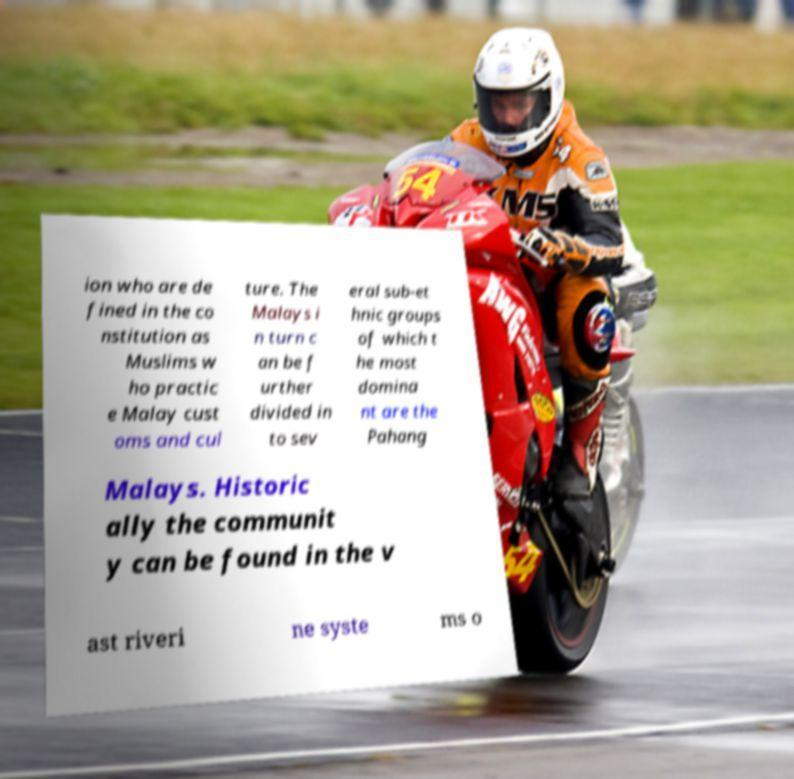There's text embedded in this image that I need extracted. Can you transcribe it verbatim? ion who are de fined in the co nstitution as Muslims w ho practic e Malay cust oms and cul ture. The Malays i n turn c an be f urther divided in to sev eral sub-et hnic groups of which t he most domina nt are the Pahang Malays. Historic ally the communit y can be found in the v ast riveri ne syste ms o 